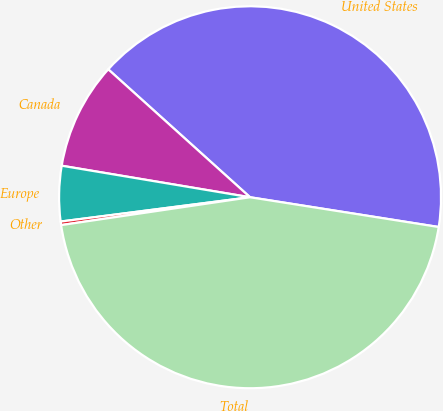Convert chart to OTSL. <chart><loc_0><loc_0><loc_500><loc_500><pie_chart><fcel>United States<fcel>Canada<fcel>Europe<fcel>Other<fcel>Total<nl><fcel>40.81%<fcel>9.04%<fcel>4.67%<fcel>0.3%<fcel>45.18%<nl></chart> 